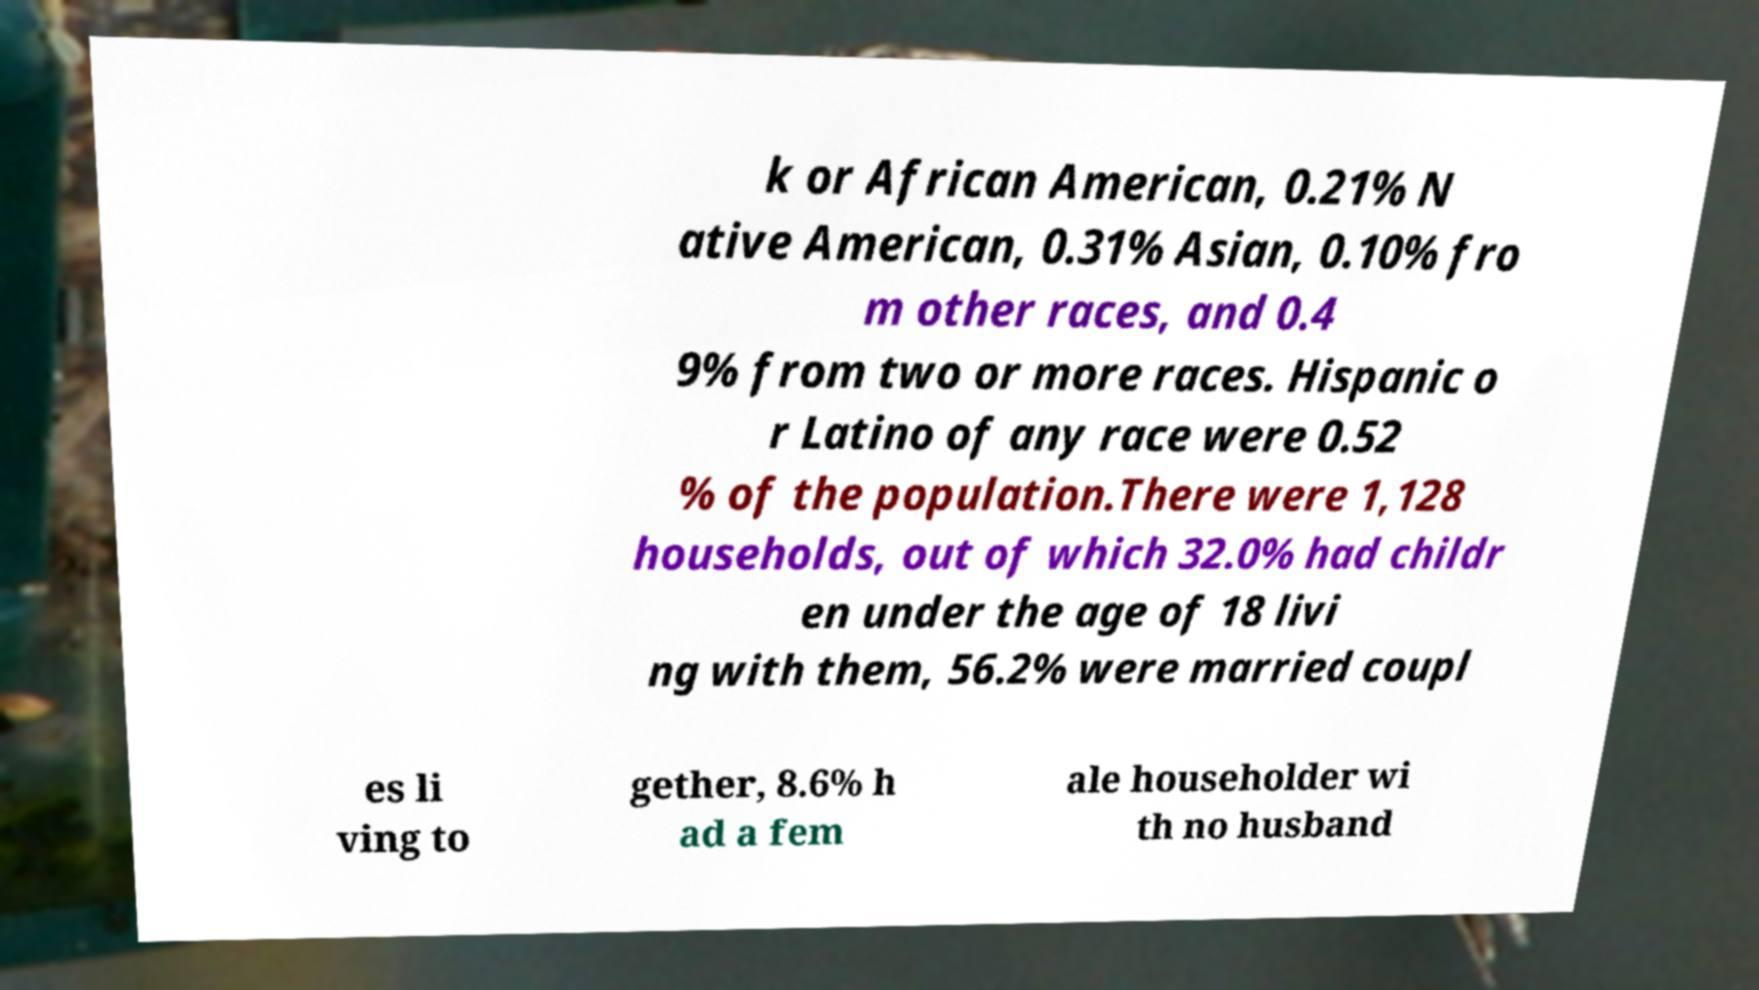Please read and relay the text visible in this image. What does it say? k or African American, 0.21% N ative American, 0.31% Asian, 0.10% fro m other races, and 0.4 9% from two or more races. Hispanic o r Latino of any race were 0.52 % of the population.There were 1,128 households, out of which 32.0% had childr en under the age of 18 livi ng with them, 56.2% were married coupl es li ving to gether, 8.6% h ad a fem ale householder wi th no husband 